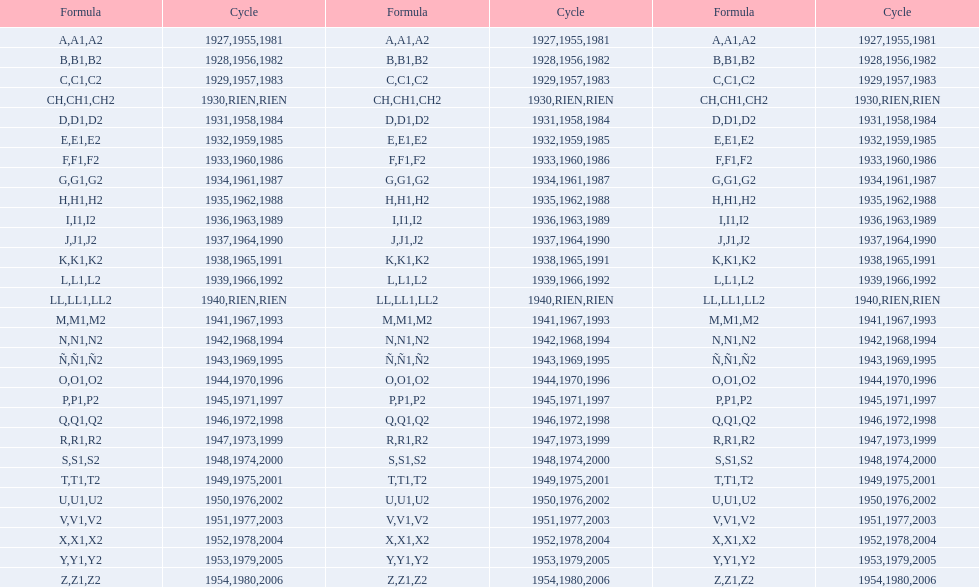List each code not associated to a year. CH1, CH2, LL1, LL2. 